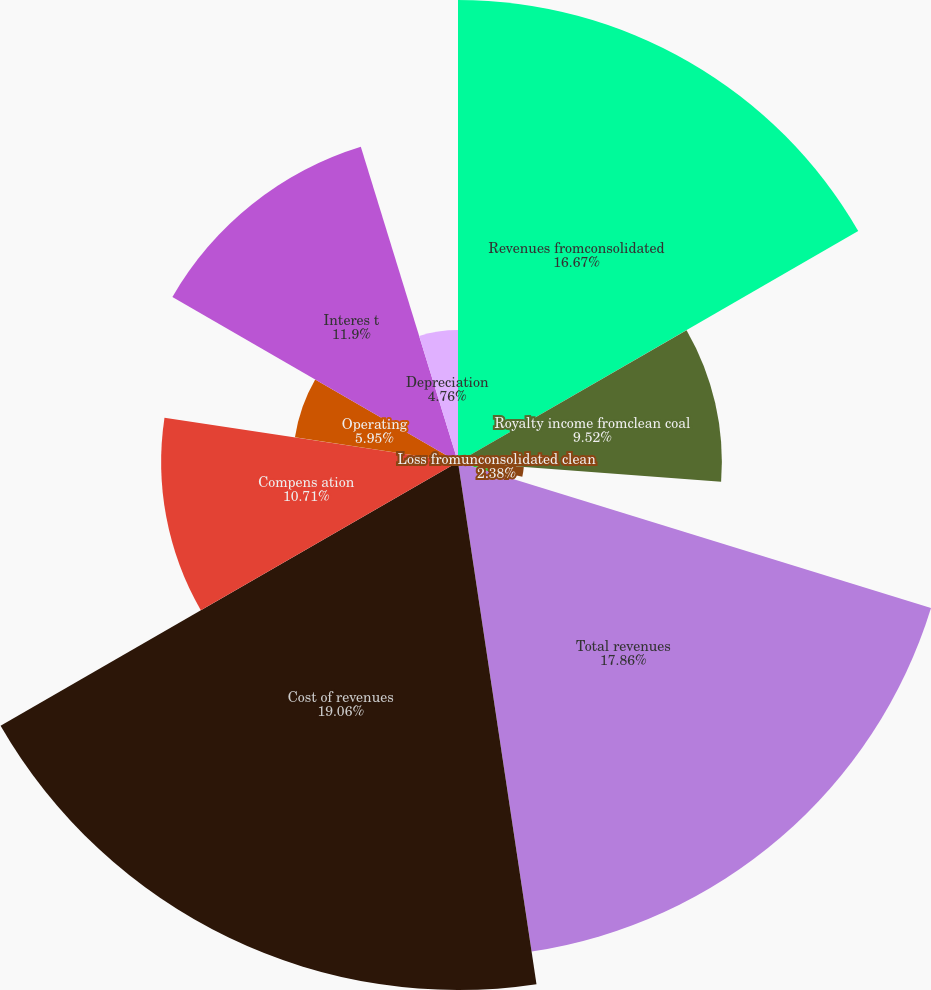Convert chart to OTSL. <chart><loc_0><loc_0><loc_500><loc_500><pie_chart><fcel>Revenues fromconsolidated<fcel>Royalty income fromclean coal<fcel>Loss fromunconsolidated clean<fcel>Other net revenues<fcel>Total revenues<fcel>Cost of revenues<fcel>Compens ation<fcel>Operating<fcel>Interes t<fcel>Depreciation<nl><fcel>16.67%<fcel>9.52%<fcel>2.38%<fcel>1.19%<fcel>17.86%<fcel>19.05%<fcel>10.71%<fcel>5.95%<fcel>11.9%<fcel>4.76%<nl></chart> 